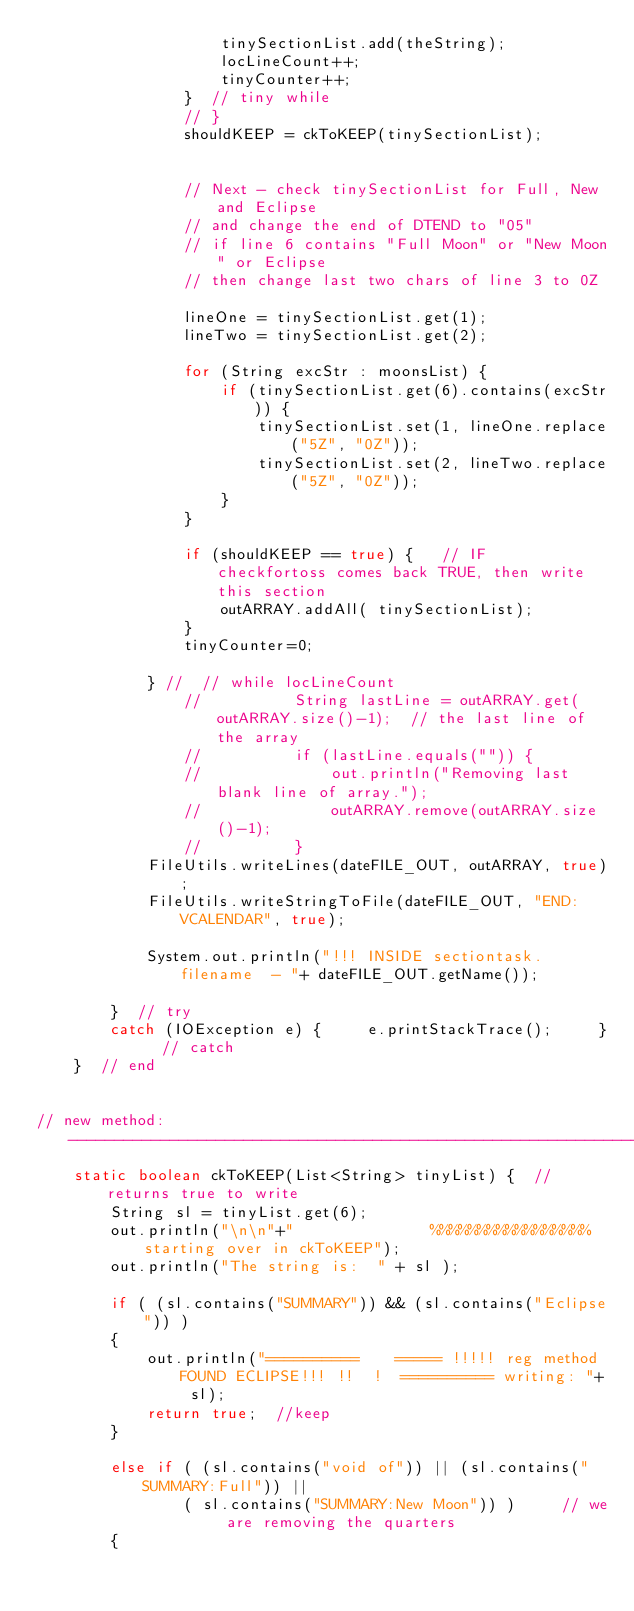<code> <loc_0><loc_0><loc_500><loc_500><_Java_>					tinySectionList.add(theString);
					locLineCount++;
					tinyCounter++;
				}  // tiny while
				// }
				shouldKEEP = ckToKEEP(tinySectionList);	 

				
				// Next - check tinySectionList for Full, New and Eclipse
				// and change the end of DTEND to "05"
				// if line 6 contains "Full Moon" or "New Moon" or Eclipse
				// then change last two chars of line 3 to 0Z

				lineOne = tinySectionList.get(1);
				lineTwo = tinySectionList.get(2);

				for (String excStr : moonsList) {
					if (tinySectionList.get(6).contains(excStr)) {
						tinySectionList.set(1, lineOne.replace("5Z", "0Z"));
						tinySectionList.set(2, lineTwo.replace("5Z", "0Z"));
					}	
				}		

				if (shouldKEEP == true) {   // IF 	checkfortoss comes back TRUE, then write this section
					outARRAY.addAll( tinySectionList);
				}
				tinyCounter=0;

			} //  // while locLineCount
				//			String lastLine = outARRAY.get( outARRAY.size()-1);  // the last line of the array
				//			if (lastLine.equals("")) {
				//				out.println("Removing last blank line of array.");
				//				outARRAY.remove(outARRAY.size()-1);
				//			}
			FileUtils.writeLines(dateFILE_OUT, outARRAY, true);	
			FileUtils.writeStringToFile(dateFILE_OUT, "END:VCALENDAR", true);
		 
			System.out.println("!!! INSIDE sectiontask. filename  - "+ dateFILE_OUT.getName());			
		}  // try  
		catch (IOException e) {  	e.printStackTrace();	 }	// catch
	}  // end

	
// new method: ----------------------------------------------------------------
	static boolean ckToKEEP(List<String> tinyList) {  // returns true to write
		String sl = tinyList.get(6);
		out.println("\n\n"+"               %%%%%%%%%%%%%%%%% starting over in ckToKEEP");
		out.println("The string is:  " + sl );

		if ( (sl.contains("SUMMARY")) && (sl.contains("Eclipse")) )
		{
			out.println("==========    ===== !!!!! reg method FOUND ECLIPSE!!! !!  !  ========== writing: "+ sl);		
			return true;  //keep
		}

		else if ( (sl.contains("void of")) || (sl.contains("SUMMARY:Full")) || 
				( sl.contains("SUMMARY:New Moon")) )     // we are removing the quarters
		{</code> 